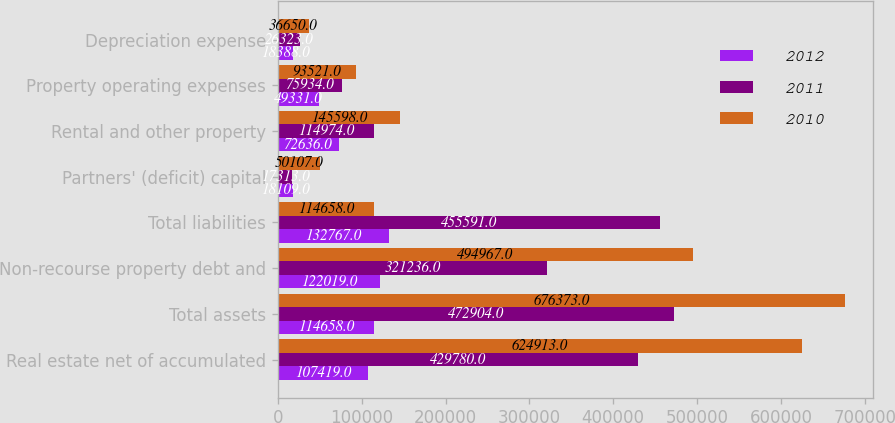Convert chart to OTSL. <chart><loc_0><loc_0><loc_500><loc_500><stacked_bar_chart><ecel><fcel>Real estate net of accumulated<fcel>Total assets<fcel>Non-recourse property debt and<fcel>Total liabilities<fcel>Partners' (deficit) capital<fcel>Rental and other property<fcel>Property operating expenses<fcel>Depreciation expense<nl><fcel>2012<fcel>107419<fcel>114658<fcel>122019<fcel>132767<fcel>18109<fcel>72636<fcel>49331<fcel>18388<nl><fcel>2011<fcel>429780<fcel>472904<fcel>321236<fcel>455591<fcel>17313<fcel>114974<fcel>75934<fcel>26323<nl><fcel>2010<fcel>624913<fcel>676373<fcel>494967<fcel>114658<fcel>50107<fcel>145598<fcel>93521<fcel>36650<nl></chart> 